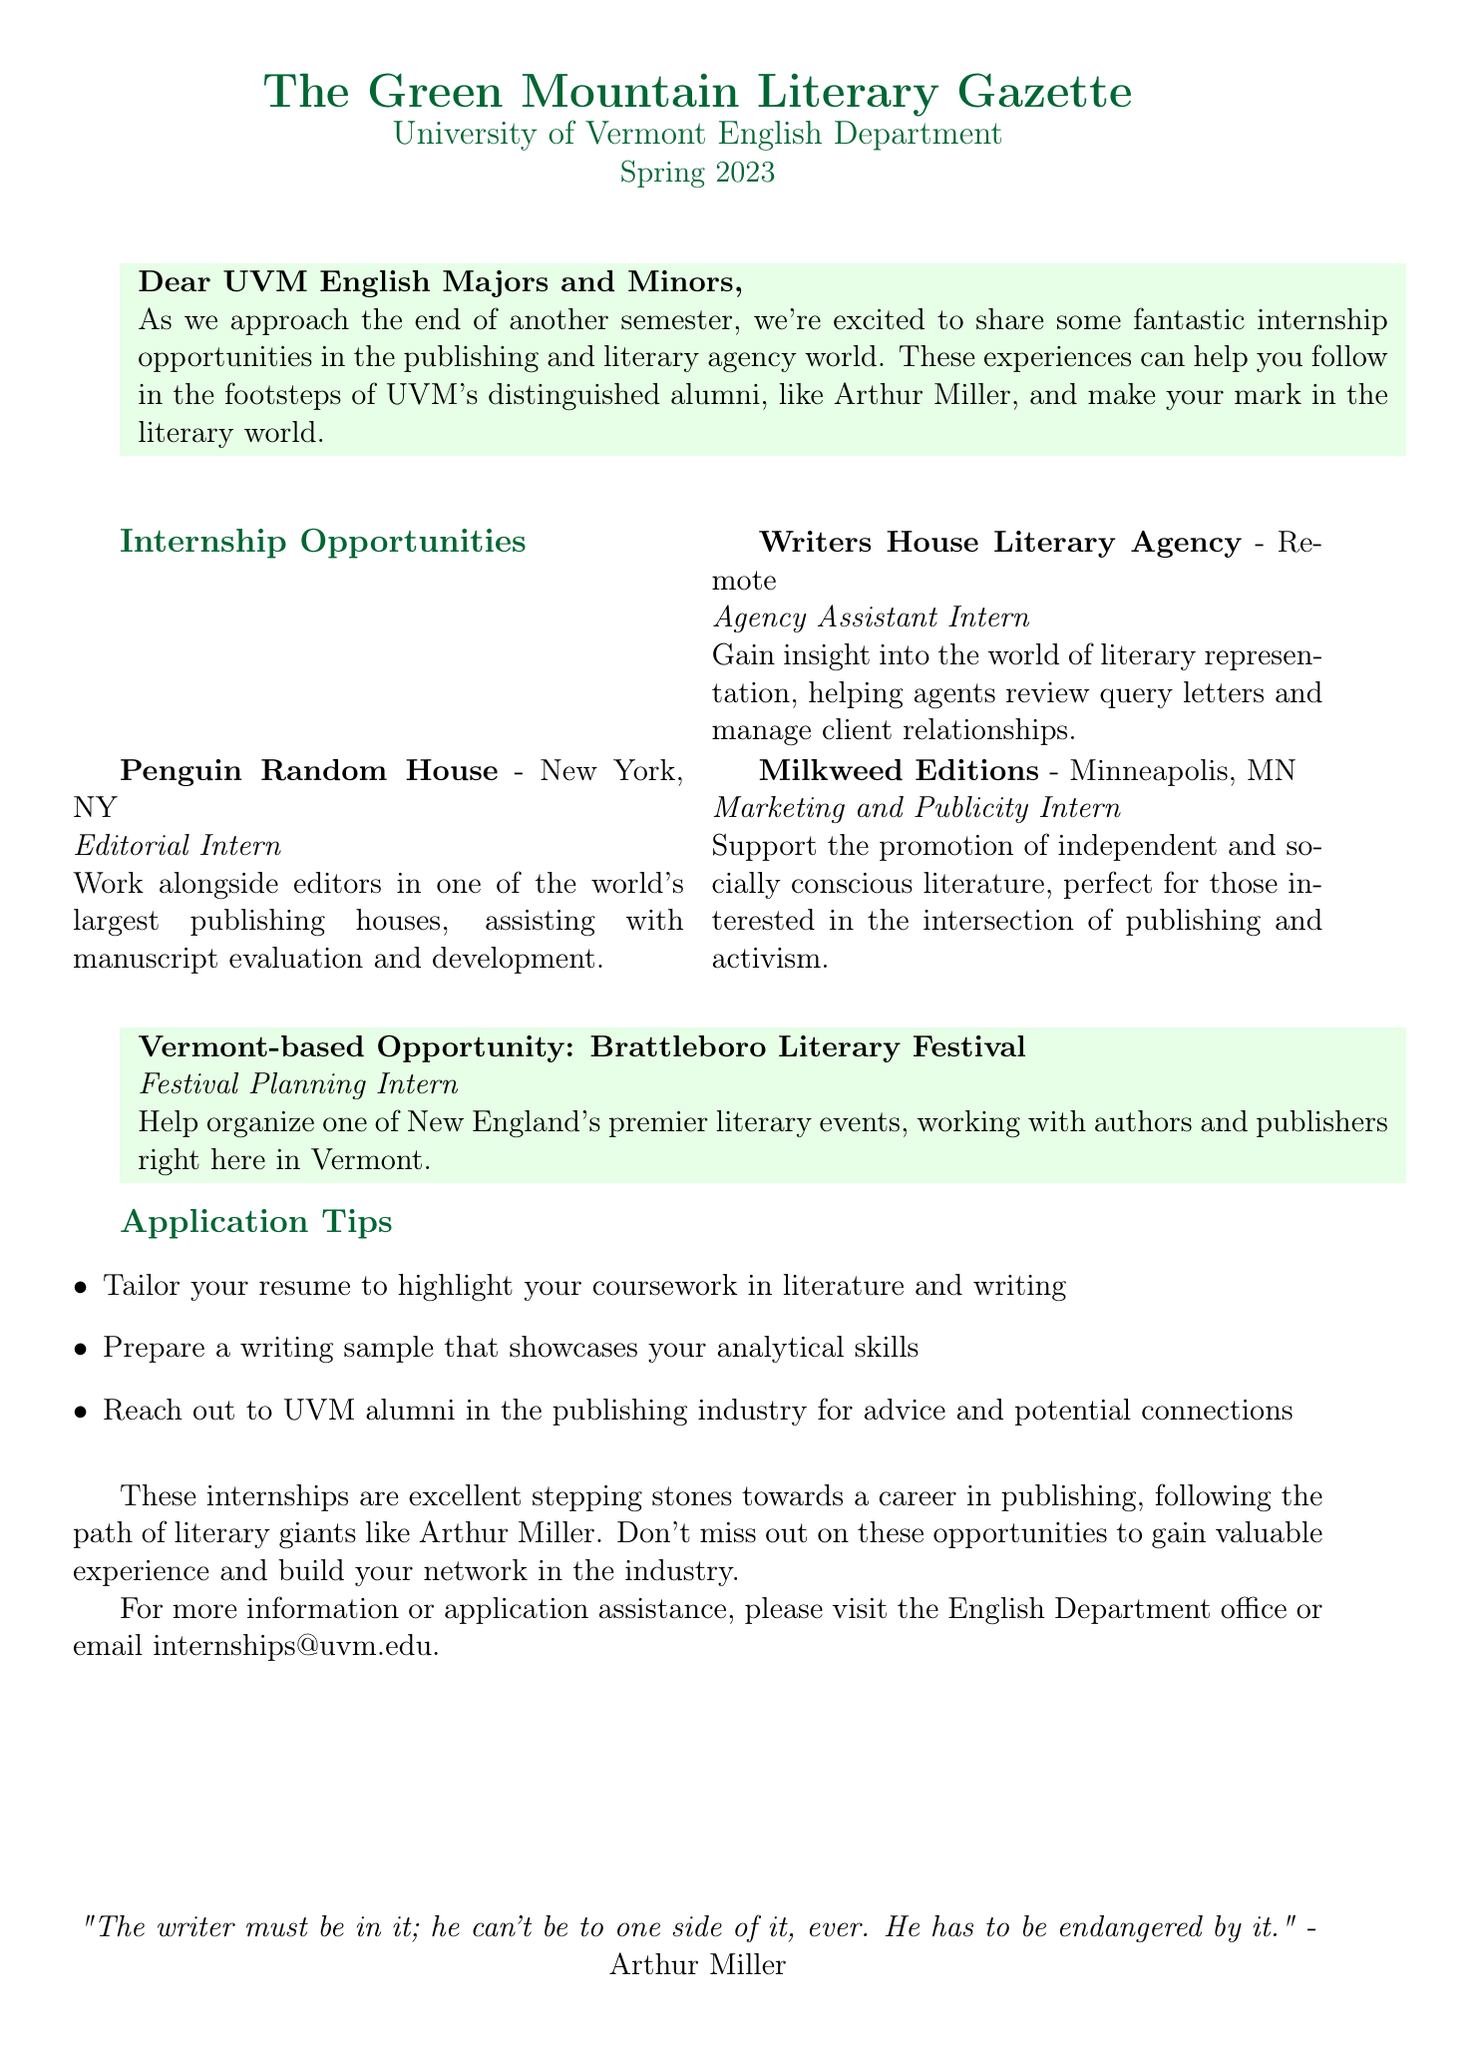What is the title of the newsletter? The title of the newsletter is explicitly stated in the header at the top of the document.
Answer: The Green Mountain Literary Gazette What position is available at Penguin Random House? The position listed under Penguin Random House in the internship opportunities section highlights the specific role.
Answer: Editorial Intern What company is offering a remote internship? The document mentions the company that offers an opportunity to work from anywhere, which is highlighted in the internship section.
Answer: Writers House Literary Agency What is a key application tip mentioned in the document? The application tips are specifically listed, providing targeted advice for applicants.
Answer: Tailor your resume to highlight your coursework in literature and writing What is the location of Milkweed Editions? The location of Milkweed Editions is provided next to the company's name in the internship opportunities section.
Answer: Minneapolis, MN What is the special highlight opportunity based in Vermont? This information is clearly defined in a dedicated segment about opportunities in the local area.
Answer: Brattleboro Literary Festival How can students contact the English Department for application assistance? The document provides a specific contact method for students seeking more information related to internship applications.
Answer: internships@uvm.edu Which quote by Arthur Miller is included in the document? The quote from Arthur Miller is presented at the bottom of the document, emphasizing its significance within the context of literature.
Answer: "The writer must be in it; he can't be to one side of it, ever. He has to be endangered by it." What month does the Spring 2023 issue refer to? The opening section of the document states the specific period this issue is addressing, linking it to the semester timeline.
Answer: May 